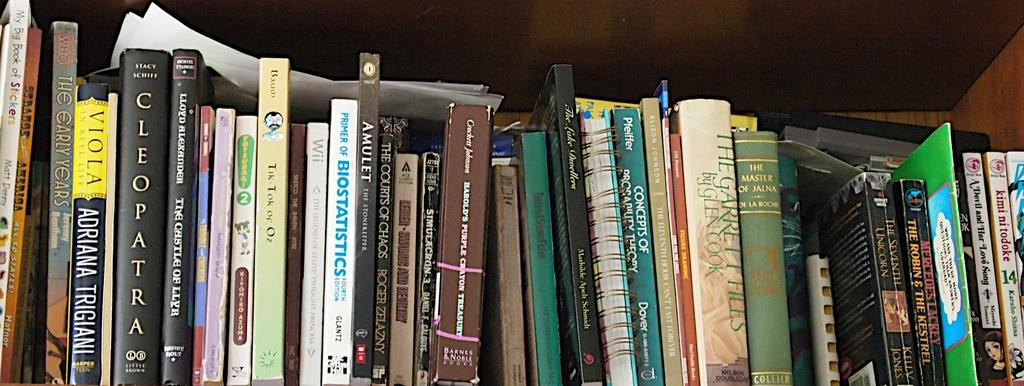Provide a one-sentence caption for the provided image. A shelf full of books including Cleopatra and The Master of Jauna. 